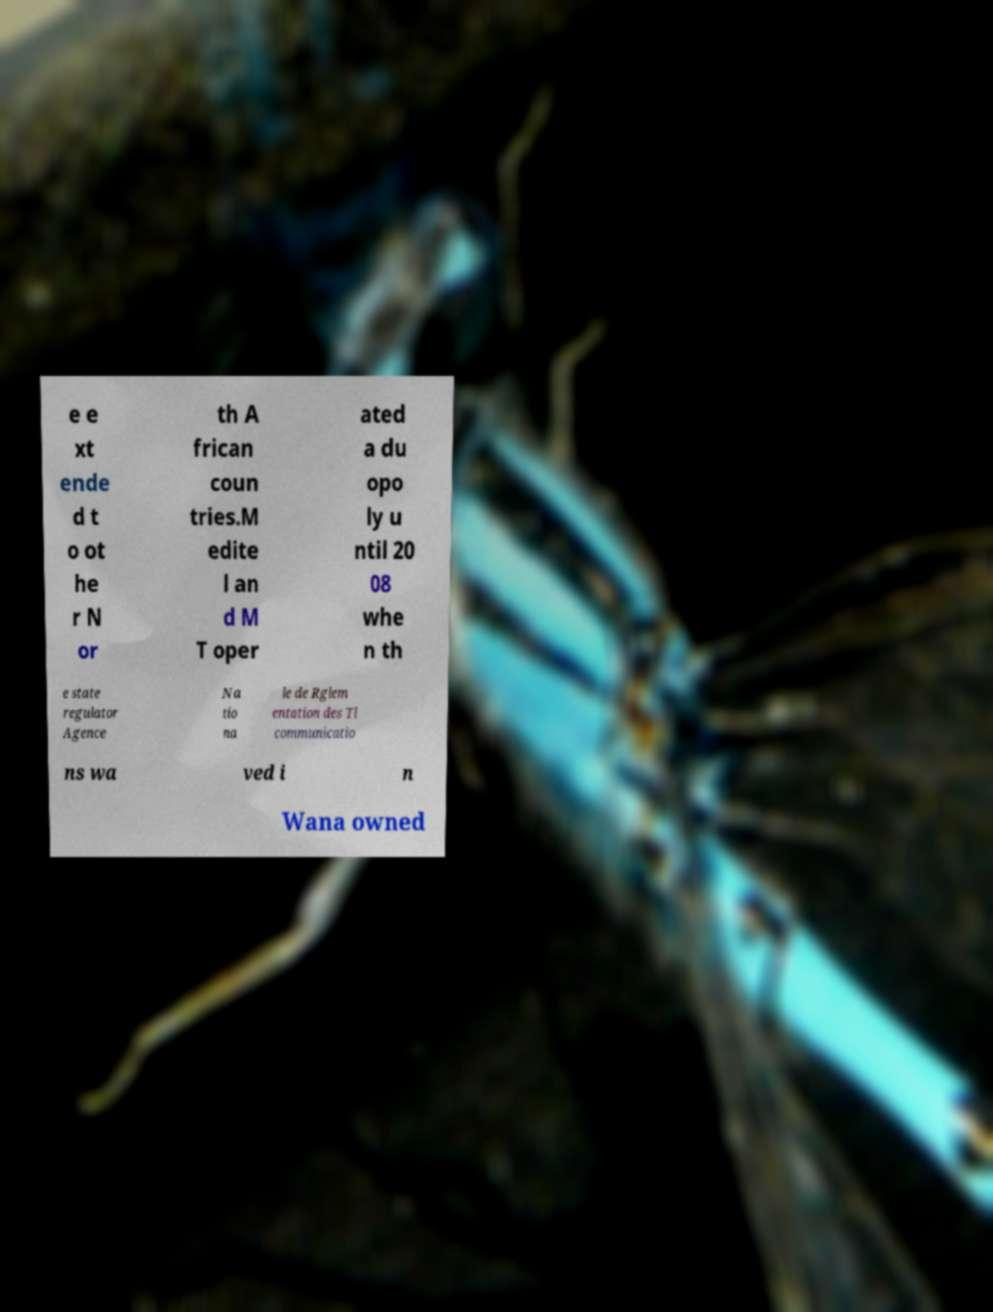Please identify and transcribe the text found in this image. e e xt ende d t o ot he r N or th A frican coun tries.M edite l an d M T oper ated a du opo ly u ntil 20 08 whe n th e state regulator Agence Na tio na le de Rglem entation des Tl communicatio ns wa ved i n Wana owned 